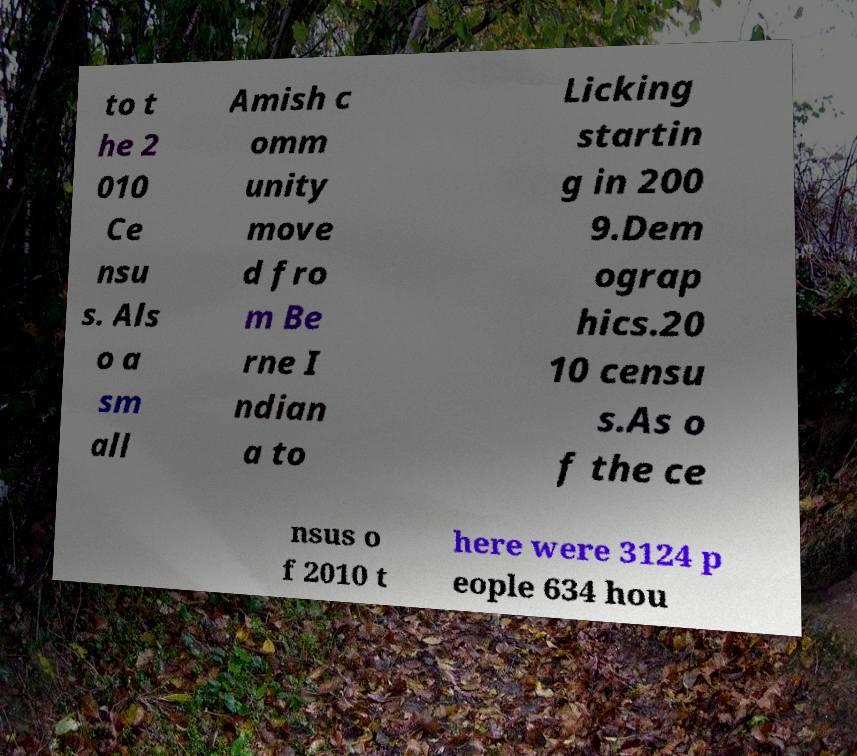Can you accurately transcribe the text from the provided image for me? to t he 2 010 Ce nsu s. Als o a sm all Amish c omm unity move d fro m Be rne I ndian a to Licking startin g in 200 9.Dem ograp hics.20 10 censu s.As o f the ce nsus o f 2010 t here were 3124 p eople 634 hou 